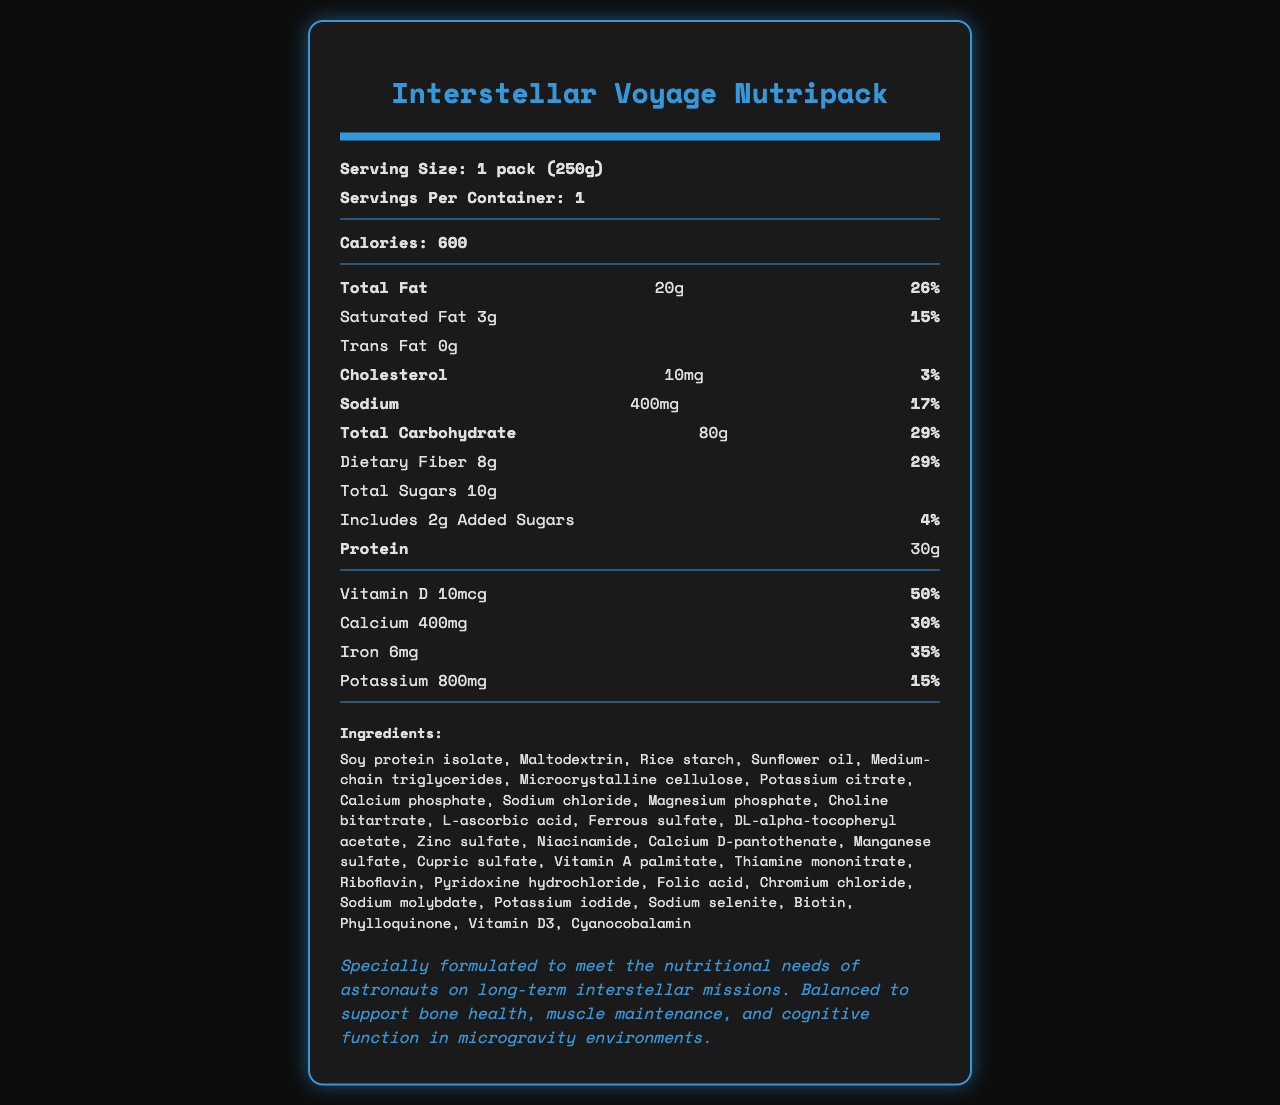what is the name of the product? The product name is mentioned at the very top of the document.
Answer: Interstellar Voyage Nutripack what is the serving size? The serving size is explicitly stated as "1 pack (250g)" near the top of the document.
Answer: 1 pack (250g) how many calories are in one serving? The calorie content per serving is listed as 600 calories.
Answer: 600 what percentage of the daily value of protein is provided in one serving? The percentage of the daily value for protein is not given in the document.
Answer: Not mentioned which ingredient is listed first? Soy protein isolate is listed as the first ingredient under the ingredients section.
Answer: Soy protein isolate how much total fat is in one serving? The total fat content per serving is 20g.
Answer: 20g what is the daily value percentage for calcium? The daily value for calcium is listed as 30%.
Answer: 30% does this product contain any trans fat? The document states that the trans fat content is 0g.
Answer: No how long is the shelf life of this product? The shelf life is mentioned as 5 years from the date of manufacture when stored as directed.
Answer: 5 years from date of manufacture what storage conditions are recommended? The recommended storage instructions are to store in a cool, dry place and to consume within 4 hours once opened.
Answer: Store in a cool, dry place. Once opened, consume within 4 hours. for which type of mission is this product specifically formulated? The document specifies that the product is formulated for long-term interstellar missions under the mission-specific information section.
Answer: Long-term interstellar missions how much vitamin C is provided per serving? The amount of vitamin C per serving is 90mg.
Answer: 90mg what is the percentage daily value for dietary fiber in one serving? The percentage daily value for dietary fiber is listed as 29%.
Answer: 29% which of the following is not an ingredient in this product? A. Soy protein isolate B. Maltodextrin C. Sugar D. Ferrous sulfate Sugar is not listed explicitly in the ingredients section, although total sugars are mentioned in the nutrition facts.
Answer: C. Sugar what percentage of the daily value for Vitamin D is in one serving? A. 15% B. 50% C. 100% The daily value percentage for Vitamin D is listed as 50%.
Answer: B. 50% can this product be recycled? The document states that the package is made from recyclable materials and suggests recycling where facilities exist.
Answer: Yes how many grams of fiber are in a serving? The amount of dietary fiber per serving is 8g.
Answer: 8g does this product support bone health, muscle maintenance, and cognitive function in a microgravity environment? The mission-specific information section mentions that the product is balanced to support bone health, muscle maintenance, and cognitive function in microgravity environments.
Answer: Yes summarize the main idea of the document. The main idea of the document is to provide comprehensive nutritional and functional information about the space food ration designed for long-term interstellar missions, including its nutritional content, preparation, and storage guidelines.
Answer: This document is a nutrition facts label for the "Interstellar Voyage Nutripack," a space food ration designed for long-term interstellar missions. It details the serving size, caloric content, nutrient percentages, ingredients, allergen information, storage and preparation instructions, and special formulations to support astronauts' health in space. what are the economic implications of investing in this product? The document mentions the potential applications in addressing global food security challenges but does not provide detailed economic implications.
Answer: Not enough information 